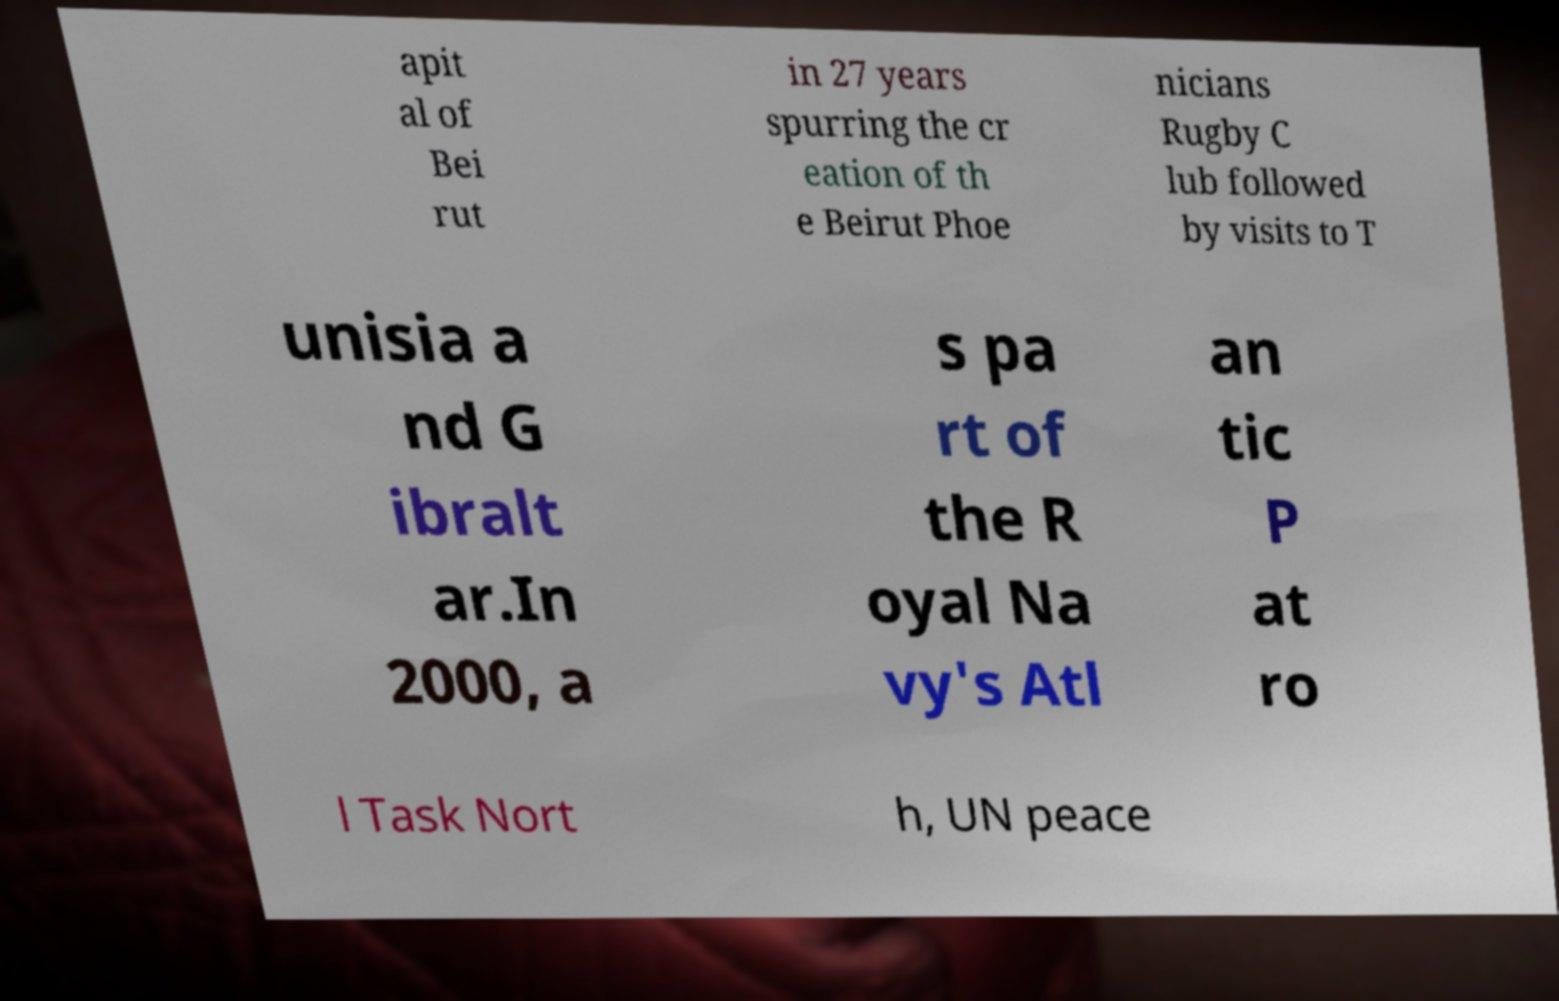Could you assist in decoding the text presented in this image and type it out clearly? apit al of Bei rut in 27 years spurring the cr eation of th e Beirut Phoe nicians Rugby C lub followed by visits to T unisia a nd G ibralt ar.In 2000, a s pa rt of the R oyal Na vy's Atl an tic P at ro l Task Nort h, UN peace 